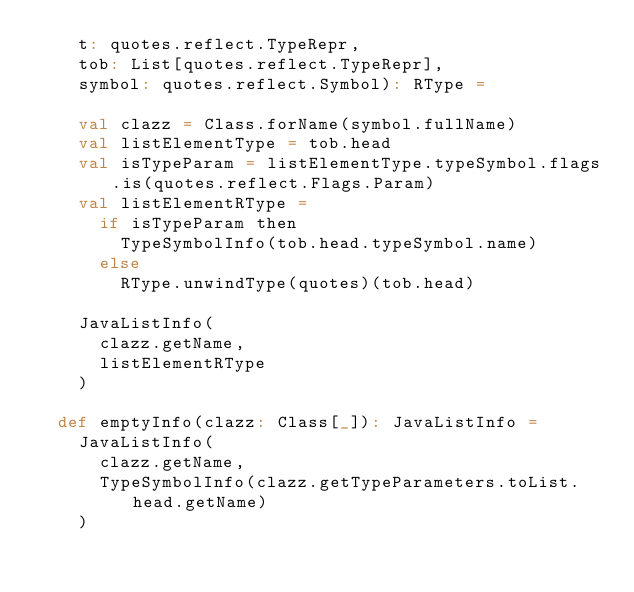Convert code to text. <code><loc_0><loc_0><loc_500><loc_500><_Scala_>    t: quotes.reflect.TypeRepr, 
    tob: List[quotes.reflect.TypeRepr], 
    symbol: quotes.reflect.Symbol): RType = 

    val clazz = Class.forName(symbol.fullName)
    val listElementType = tob.head
    val isTypeParam = listElementType.typeSymbol.flags.is(quotes.reflect.Flags.Param)
    val listElementRType = 
      if isTypeParam then
        TypeSymbolInfo(tob.head.typeSymbol.name)
      else
        RType.unwindType(quotes)(tob.head)

    JavaListInfo(
      clazz.getName, 
      listElementRType
    )

  def emptyInfo(clazz: Class[_]): JavaListInfo = 
    JavaListInfo(
      clazz.getName, 
      TypeSymbolInfo(clazz.getTypeParameters.toList.head.getName)
    )
</code> 